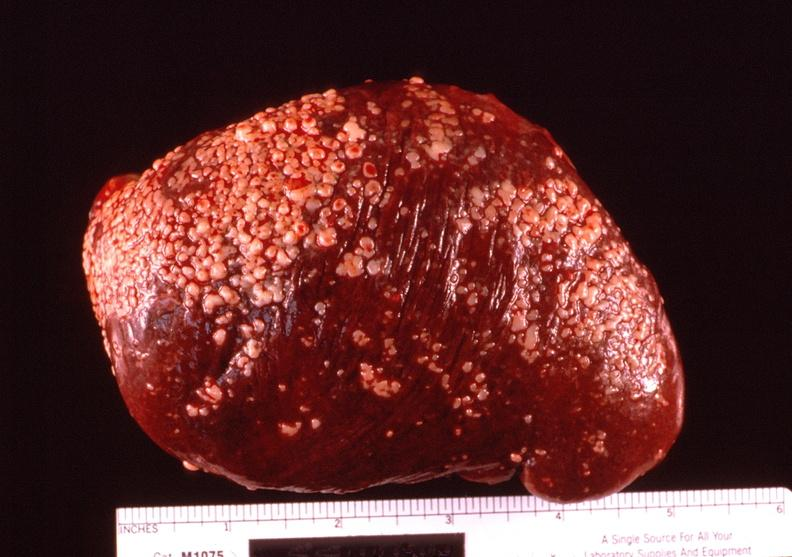does side show spleen, hyaline perisplenitis associated with ascites?
Answer the question using a single word or phrase. No 